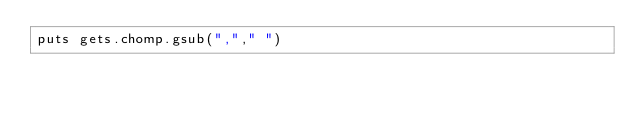<code> <loc_0><loc_0><loc_500><loc_500><_Ruby_>puts gets.chomp.gsub(","," ")</code> 